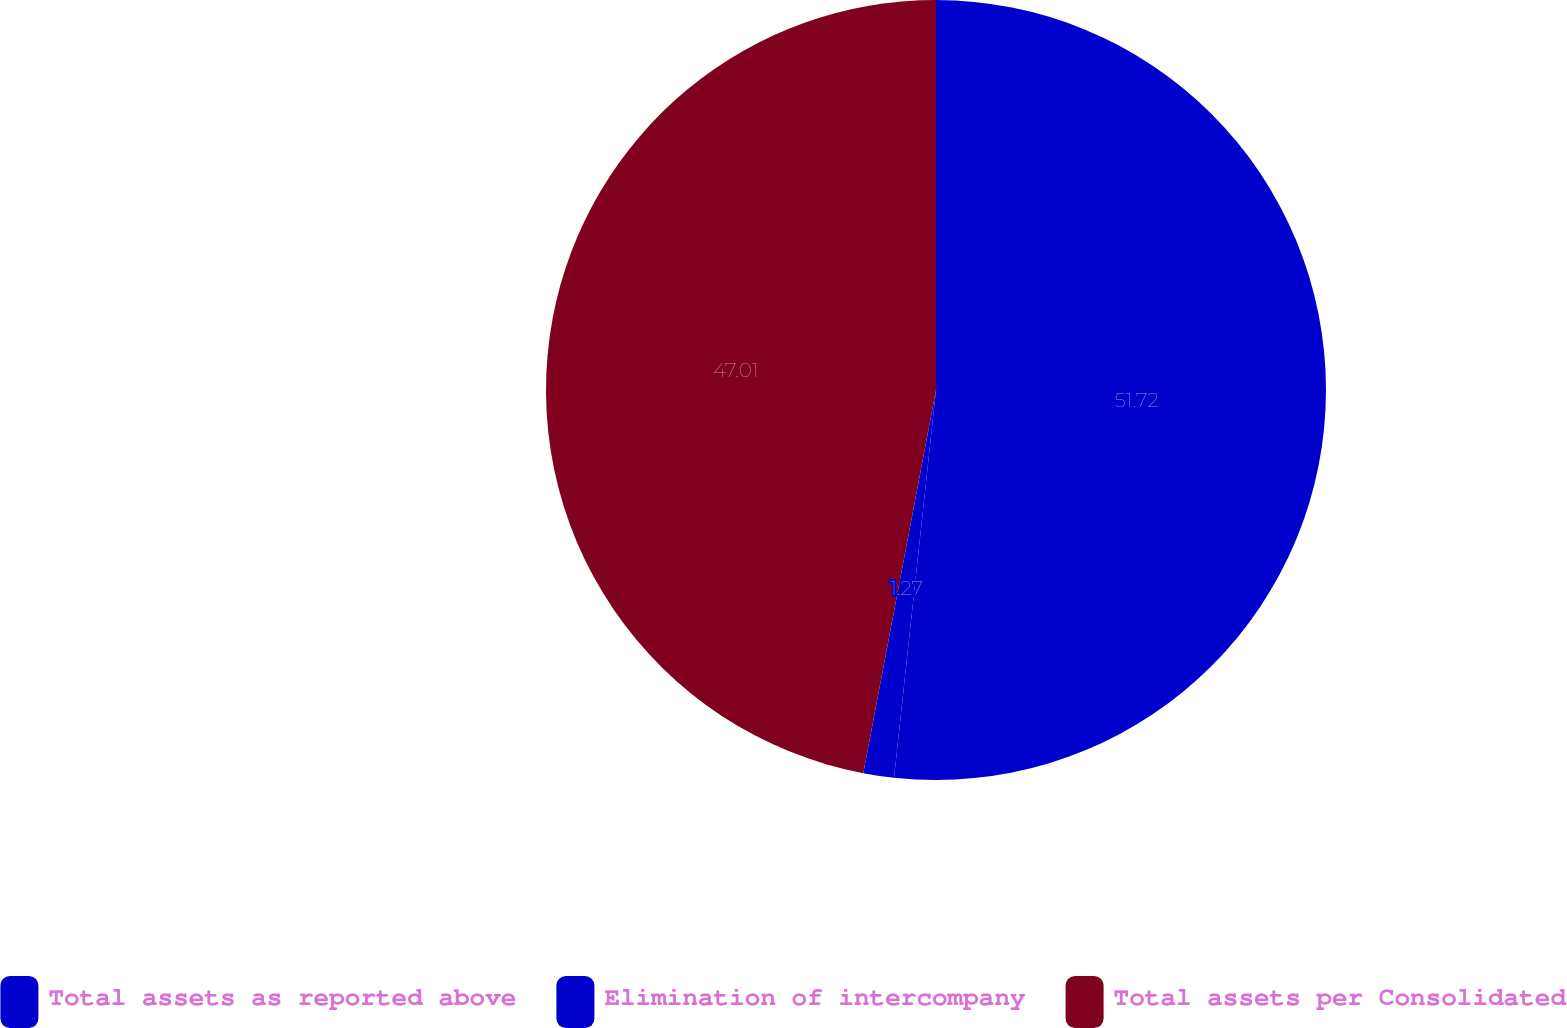Convert chart. <chart><loc_0><loc_0><loc_500><loc_500><pie_chart><fcel>Total assets as reported above<fcel>Elimination of intercompany<fcel>Total assets per Consolidated<nl><fcel>51.71%<fcel>1.27%<fcel>47.01%<nl></chart> 